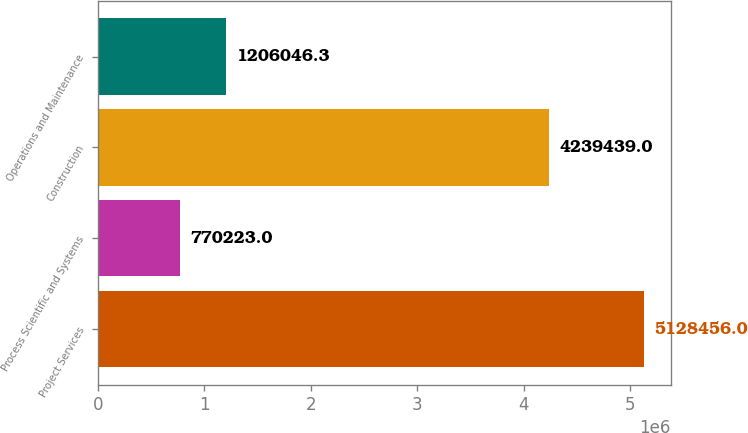Convert chart. <chart><loc_0><loc_0><loc_500><loc_500><bar_chart><fcel>Project Services<fcel>Process Scientific and Systems<fcel>Construction<fcel>Operations and Maintenance<nl><fcel>5.12846e+06<fcel>770223<fcel>4.23944e+06<fcel>1.20605e+06<nl></chart> 